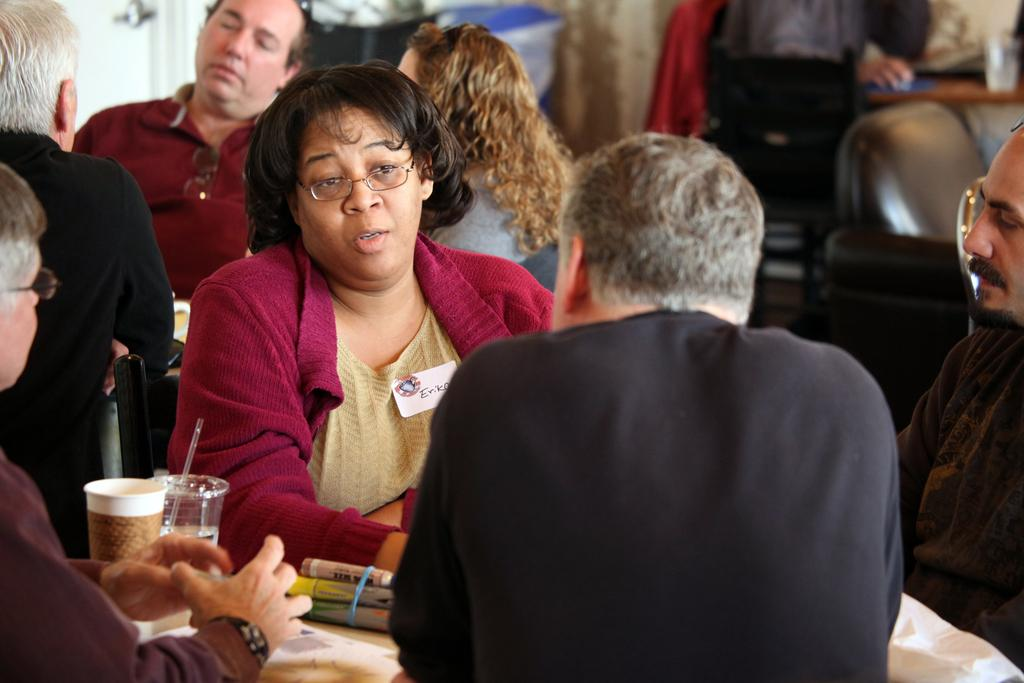What are the people in the image doing? The people in the image are sitting on chairs. What objects are in front of the chairs? Tables are present in front of the chairs. What type of containers are on the tables? Disposable tumblers are on the tables. What else can be found on the tables? Papers and markers are on the tables. What type of cloud can be seen in the image? There is no cloud present in the image; it is focused on people sitting on chairs with tables in front of them. 